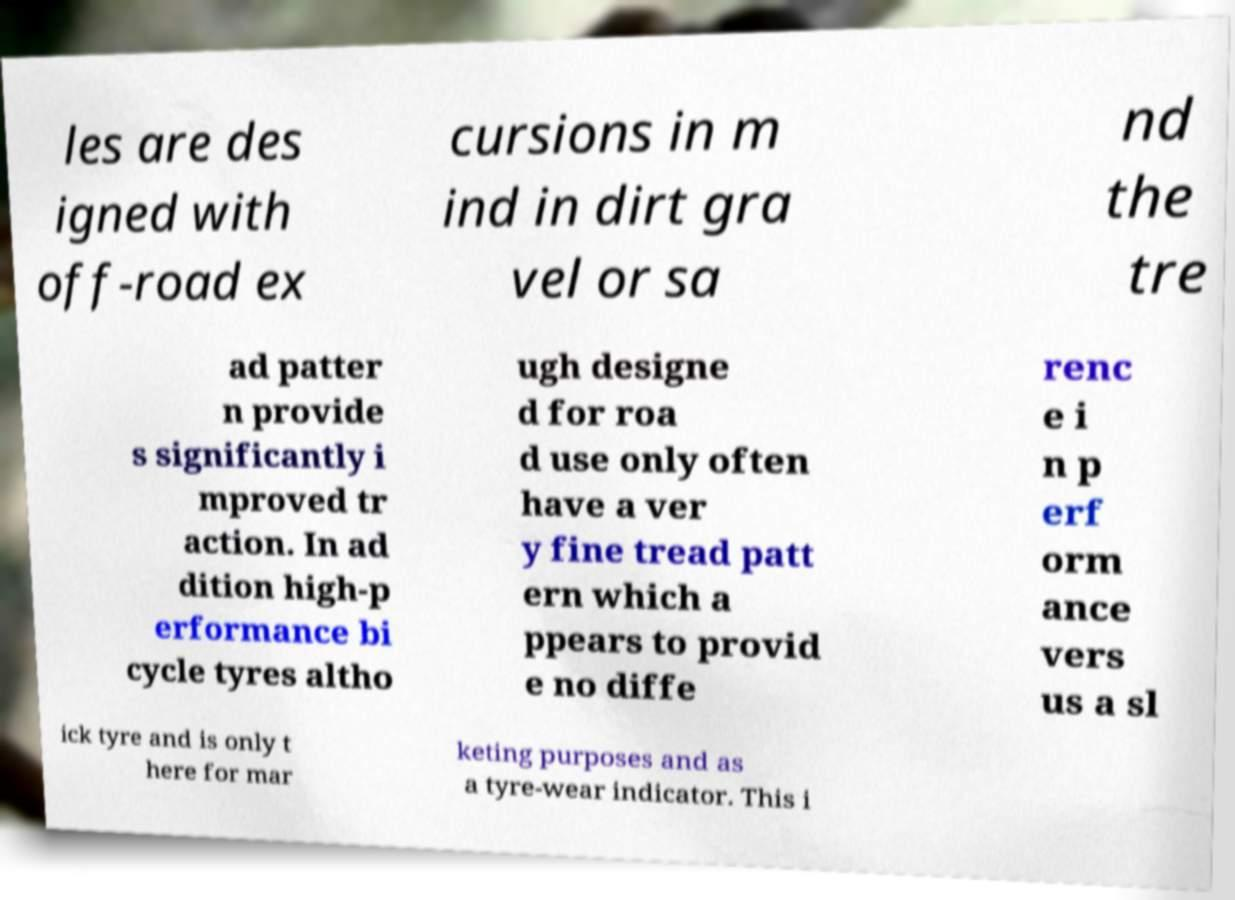There's text embedded in this image that I need extracted. Can you transcribe it verbatim? les are des igned with off-road ex cursions in m ind in dirt gra vel or sa nd the tre ad patter n provide s significantly i mproved tr action. In ad dition high-p erformance bi cycle tyres altho ugh designe d for roa d use only often have a ver y fine tread patt ern which a ppears to provid e no diffe renc e i n p erf orm ance vers us a sl ick tyre and is only t here for mar keting purposes and as a tyre-wear indicator. This i 